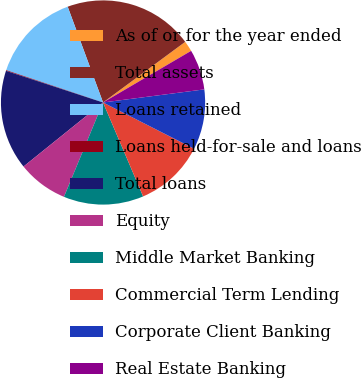Convert chart. <chart><loc_0><loc_0><loc_500><loc_500><pie_chart><fcel>As of or for the year ended<fcel>Total assets<fcel>Loans retained<fcel>Loans held-for-sale and loans<fcel>Total loans<fcel>Equity<fcel>Middle Market Banking<fcel>Commercial Term Lending<fcel>Corporate Client Banking<fcel>Real Estate Banking<nl><fcel>1.68%<fcel>20.51%<fcel>14.24%<fcel>0.11%<fcel>15.81%<fcel>7.96%<fcel>12.67%<fcel>11.1%<fcel>9.53%<fcel>6.39%<nl></chart> 